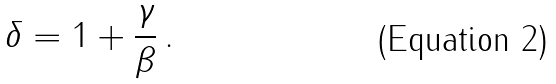<formula> <loc_0><loc_0><loc_500><loc_500>\delta = 1 + \frac { \gamma } { \beta } \, .</formula> 